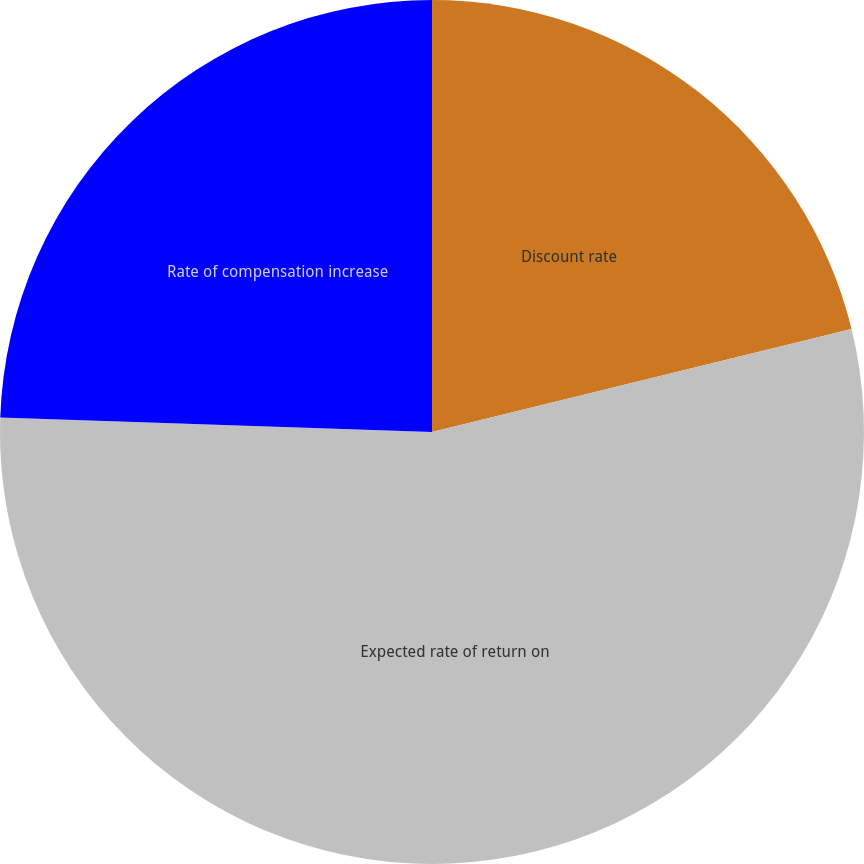<chart> <loc_0><loc_0><loc_500><loc_500><pie_chart><fcel>Discount rate<fcel>Expected rate of return on<fcel>Rate of compensation increase<nl><fcel>21.17%<fcel>54.36%<fcel>24.47%<nl></chart> 